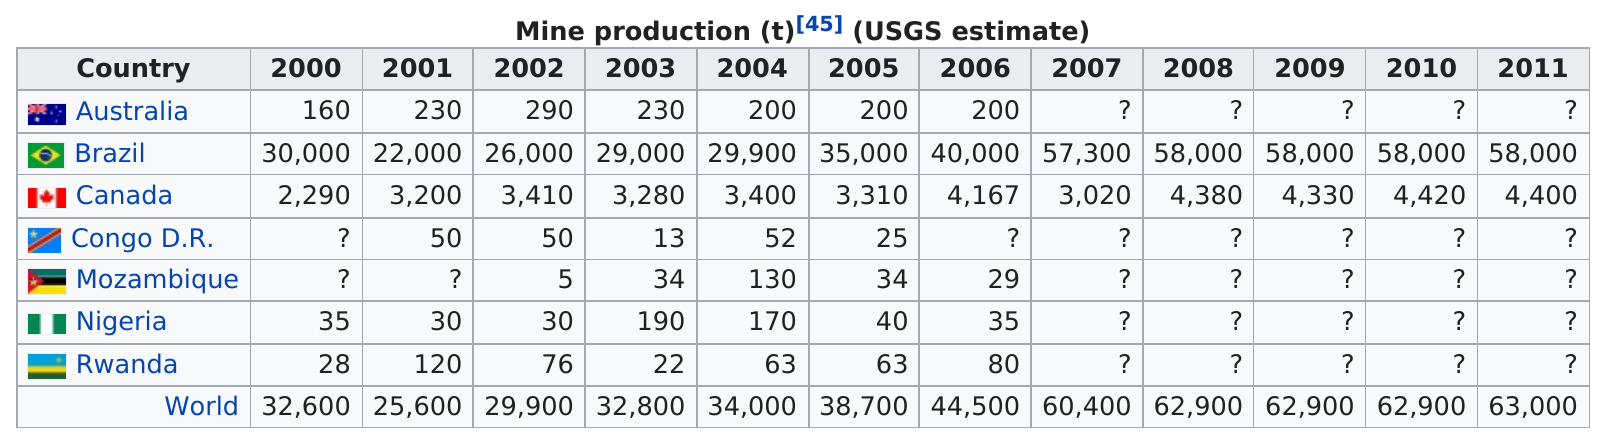Point out several critical features in this image. In 2002, the Democratic Republic of the Congo produced 50 units, but in 2003, production decreased to only 13 units. Brazil was the top producer of niobium in the year 2003. In 2002, Australia produced the most metal than any other year. The USGS estimates indicate that Rwanda produced a larger quantity of niobium mineral production in 2005 than Nigeria. In the year 2006, Australia, Mozambique, Nigeria, and Rwanda were among the countries that did not produce more than 1,000. 